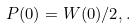<formula> <loc_0><loc_0><loc_500><loc_500>P ( 0 ) = W ( 0 ) / 2 , .</formula> 